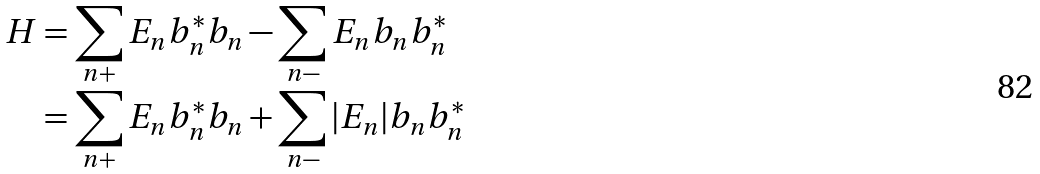Convert formula to latex. <formula><loc_0><loc_0><loc_500><loc_500>H & = \sum _ { n + } E _ { n } b ^ { * } _ { n } b _ { n } - \sum _ { n - } E _ { n } b _ { n } b ^ { * } _ { n } \\ & = \sum _ { n + } E _ { n } b ^ { * } _ { n } b _ { n } + \sum _ { n - } | E _ { n } | b _ { n } b ^ { * } _ { n }</formula> 